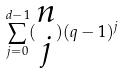<formula> <loc_0><loc_0><loc_500><loc_500>\sum _ { j = 0 } ^ { d - 1 } ( \begin{matrix} n \\ j \end{matrix} ) ( q - 1 ) ^ { j }</formula> 